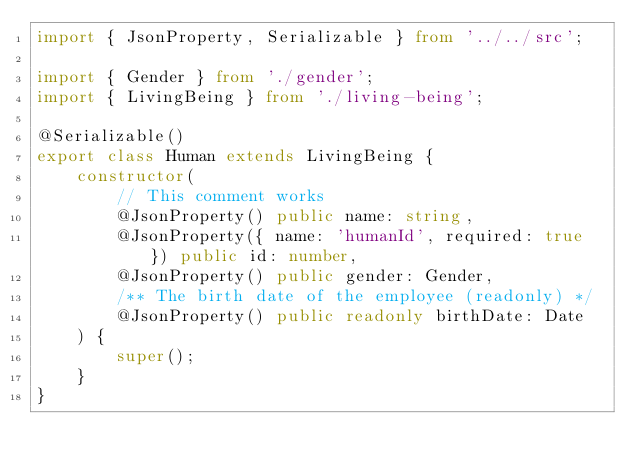Convert code to text. <code><loc_0><loc_0><loc_500><loc_500><_TypeScript_>import { JsonProperty, Serializable } from '../../src';

import { Gender } from './gender';
import { LivingBeing } from './living-being';

@Serializable()
export class Human extends LivingBeing {
    constructor(
        // This comment works
        @JsonProperty() public name: string,
        @JsonProperty({ name: 'humanId', required: true }) public id: number,
        @JsonProperty() public gender: Gender,
        /** The birth date of the employee (readonly) */
        @JsonProperty() public readonly birthDate: Date
    ) {
        super();
    }
}
</code> 